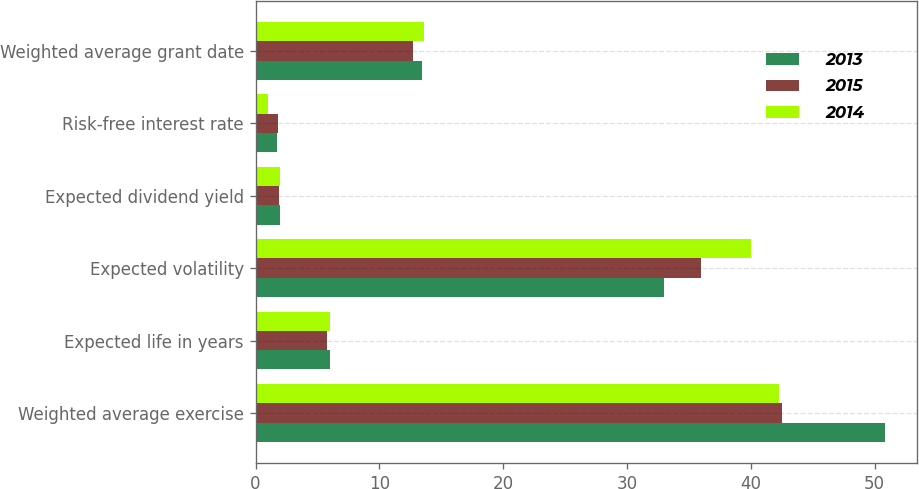Convert chart. <chart><loc_0><loc_0><loc_500><loc_500><stacked_bar_chart><ecel><fcel>Weighted average exercise<fcel>Expected life in years<fcel>Expected volatility<fcel>Expected dividend yield<fcel>Risk-free interest rate<fcel>Weighted average grant date<nl><fcel>2013<fcel>50.85<fcel>6<fcel>33<fcel>2<fcel>1.7<fcel>13.44<nl><fcel>2015<fcel>42.51<fcel>5.8<fcel>36<fcel>1.9<fcel>1.8<fcel>12.69<nl><fcel>2014<fcel>42.32<fcel>6<fcel>40<fcel>2<fcel>1<fcel>13.57<nl></chart> 